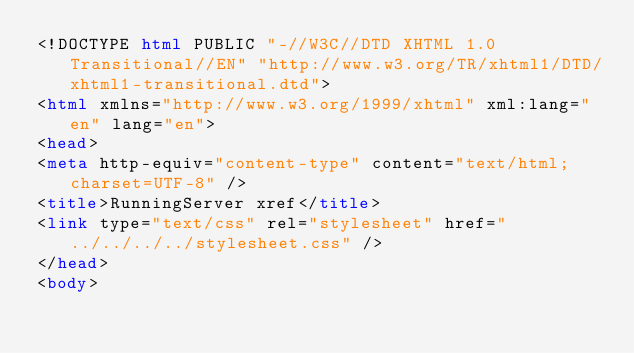<code> <loc_0><loc_0><loc_500><loc_500><_HTML_><!DOCTYPE html PUBLIC "-//W3C//DTD XHTML 1.0 Transitional//EN" "http://www.w3.org/TR/xhtml1/DTD/xhtml1-transitional.dtd">
<html xmlns="http://www.w3.org/1999/xhtml" xml:lang="en" lang="en">
<head>
<meta http-equiv="content-type" content="text/html; charset=UTF-8" />
<title>RunningServer xref</title>
<link type="text/css" rel="stylesheet" href="../../../../stylesheet.css" />
</head>
<body></code> 